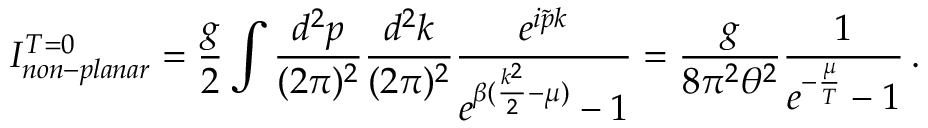<formula> <loc_0><loc_0><loc_500><loc_500>I _ { n o n - p l a n a r } ^ { T = 0 } = \frac { g } { 2 } \int \frac { d ^ { 2 } p } { ( 2 \pi ) ^ { 2 } } \frac { d ^ { 2 } k } { ( 2 \pi ) ^ { 2 } } \frac { e ^ { i \tilde { p } k } } { e ^ { \beta ( \frac { k ^ { 2 } } { 2 } - \mu ) } - 1 } = \frac { g } { 8 \pi ^ { 2 } \theta ^ { 2 } } \frac { 1 } { e ^ { - \frac { \mu } { T } } - 1 } \, .</formula> 